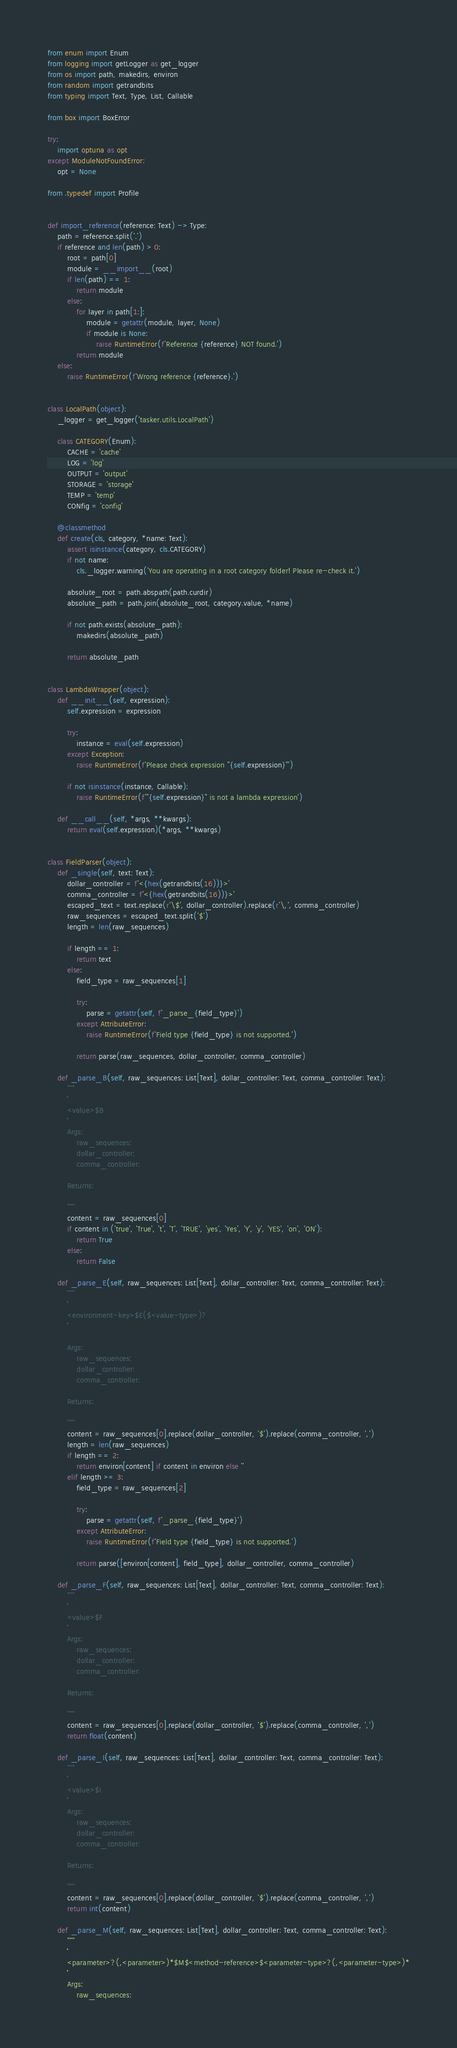<code> <loc_0><loc_0><loc_500><loc_500><_Python_>from enum import Enum
from logging import getLogger as get_logger
from os import path, makedirs, environ
from random import getrandbits
from typing import Text, Type, List, Callable

from box import BoxError

try:
    import optuna as opt
except ModuleNotFoundError:
    opt = None

from .typedef import Profile


def import_reference(reference: Text) -> Type:
    path = reference.split('.')
    if reference and len(path) > 0:
        root = path[0]
        module = __import__(root)
        if len(path) == 1:
            return module
        else:
            for layer in path[1:]:
                module = getattr(module, layer, None)
                if module is None:
                    raise RuntimeError(f'Reference {reference} NOT found.')
            return module
    else:
        raise RuntimeError(f'Wrong reference {reference}.')


class LocalPath(object):
    _logger = get_logger('tasker.utils.LocalPath')

    class CATEGORY(Enum):
        CACHE = 'cache'
        LOG = 'log'
        OUTPUT = 'output'
        STORAGE = 'storage'
        TEMP = 'temp'
        CONfig = 'config'

    @classmethod
    def create(cls, category, *name: Text):
        assert isinstance(category, cls.CATEGORY)
        if not name:
            cls._logger.warning('You are operating in a root category folder! Please re-check it.')

        absolute_root = path.abspath(path.curdir)
        absolute_path = path.join(absolute_root, category.value, *name)

        if not path.exists(absolute_path):
            makedirs(absolute_path)

        return absolute_path


class LambdaWrapper(object):
    def __init__(self, expression):
        self.expression = expression

        try:
            instance = eval(self.expression)
        except Exception:
            raise RuntimeError(f'Please check expression "{self.expression}"')

        if not isinstance(instance, Callable):
            raise RuntimeError(f'"{self.expression}" is not a lambda expression')

    def __call__(self, *args, **kwargs):
        return eval(self.expression)(*args, **kwargs)


class FieldParser(object):
    def _single(self, text: Text):
        dollar_controller = f'<{hex(getrandbits(16))}>'
        comma_controller = f'<{hex(getrandbits(16))}>'
        escaped_text = text.replace(r'\$', dollar_controller).replace(r'\,', comma_controller)
        raw_sequences = escaped_text.split('$')
        length = len(raw_sequences)

        if length == 1:
            return text
        else:
            field_type = raw_sequences[1]

            try:
                parse = getattr(self, f'_parse_{field_type}')
            except AttributeError:
                raise RuntimeError(f'Field type {field_type} is not supported.')

            return parse(raw_sequences, dollar_controller, comma_controller)

    def _parse_B(self, raw_sequences: List[Text], dollar_controller: Text, comma_controller: Text):
        """
        ```
        <value>$B
        ```
        Args:
            raw_sequences:
            dollar_controller:
            comma_controller:

        Returns:

        """
        content = raw_sequences[0]
        if content in ('true', 'True', 't', 'T', 'TRUE', 'yes', 'Yes', 'Y', 'y', 'YES', 'on', 'ON'):
            return True
        else:
            return False

    def _parse_E(self, raw_sequences: List[Text], dollar_controller: Text, comma_controller: Text):
        """
        ```
        <environment-key>$E($<value-type>)?
        ```

        Args:
            raw_sequences:
            dollar_controller:
            comma_controller:

        Returns:

        """
        content = raw_sequences[0].replace(dollar_controller, '$').replace(comma_controller, ',')
        length = len(raw_sequences)
        if length == 2:
            return environ[content] if content in environ else ''
        elif length >= 3:
            field_type = raw_sequences[2]

            try:
                parse = getattr(self, f'_parse_{field_type}')
            except AttributeError:
                raise RuntimeError(f'Field type {field_type} is not supported.')

            return parse([environ[content], field_type], dollar_controller, comma_controller)

    def _parse_F(self, raw_sequences: List[Text], dollar_controller: Text, comma_controller: Text):
        """
        ```
        <value>$F
        ```
        Args:
            raw_sequences:
            dollar_controller:
            comma_controller:

        Returns:

        """
        content = raw_sequences[0].replace(dollar_controller, '$').replace(comma_controller, ',')
        return float(content)

    def _parse_I(self, raw_sequences: List[Text], dollar_controller: Text, comma_controller: Text):
        """
        ```
        <value>$I
        ```
        Args:
            raw_sequences:
            dollar_controller:
            comma_controller:

        Returns:

        """
        content = raw_sequences[0].replace(dollar_controller, '$').replace(comma_controller, ',')
        return int(content)

    def _parse_M(self, raw_sequences: List[Text], dollar_controller: Text, comma_controller: Text):
        """
        ```
        <parameter>?(,<parameter>)*$M$<method-reference>$<parameter-type>?(,<parameter-type>)*
        ```
        Args:
            raw_sequences:</code> 